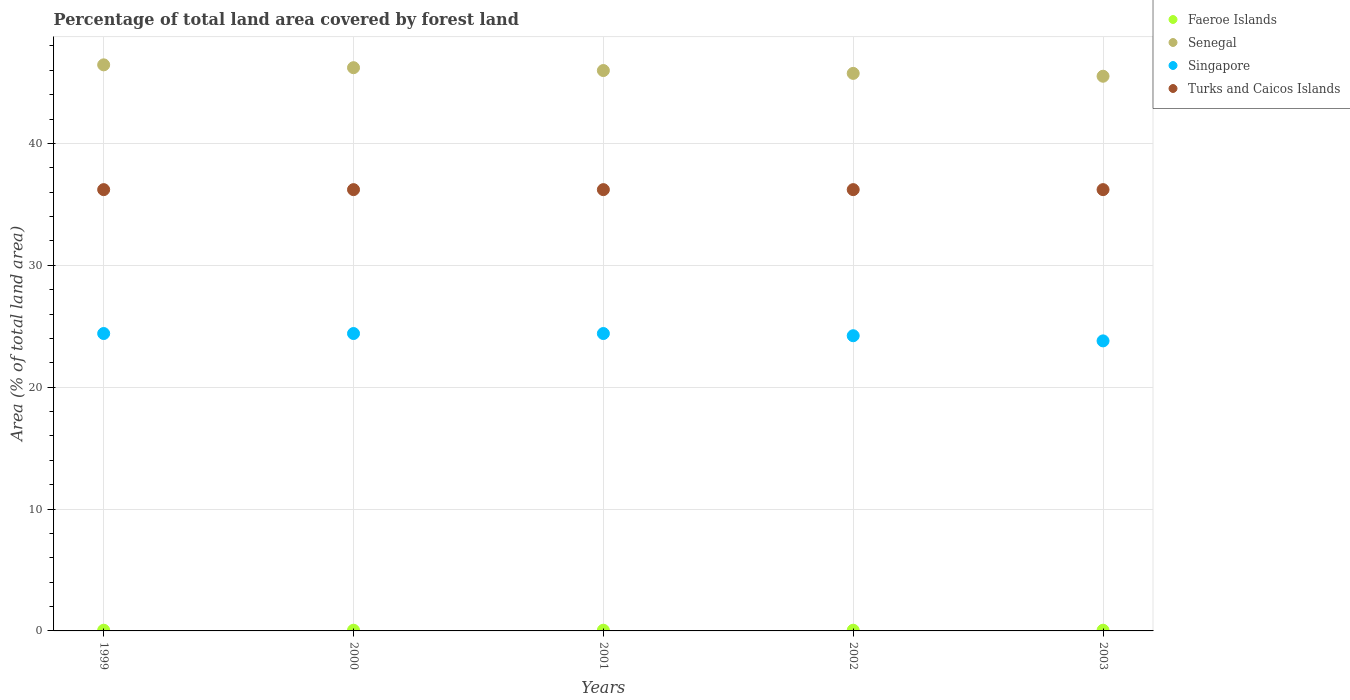How many different coloured dotlines are there?
Your answer should be very brief. 4. Is the number of dotlines equal to the number of legend labels?
Offer a very short reply. Yes. What is the percentage of forest land in Singapore in 2003?
Give a very brief answer. 23.8. Across all years, what is the maximum percentage of forest land in Faeroe Islands?
Provide a succinct answer. 0.06. Across all years, what is the minimum percentage of forest land in Turks and Caicos Islands?
Provide a short and direct response. 36.21. What is the total percentage of forest land in Singapore in the graph?
Offer a terse response. 121.23. What is the difference between the percentage of forest land in Senegal in 2001 and that in 2002?
Ensure brevity in your answer.  0.23. What is the difference between the percentage of forest land in Faeroe Islands in 2003 and the percentage of forest land in Singapore in 2001?
Your answer should be very brief. -24.35. What is the average percentage of forest land in Turks and Caicos Islands per year?
Your response must be concise. 36.21. In the year 2002, what is the difference between the percentage of forest land in Senegal and percentage of forest land in Singapore?
Give a very brief answer. 21.53. In how many years, is the percentage of forest land in Faeroe Islands greater than 26 %?
Offer a terse response. 0. What is the ratio of the percentage of forest land in Turks and Caicos Islands in 1999 to that in 2002?
Your answer should be compact. 1. What is the difference between the highest and the second highest percentage of forest land in Senegal?
Your answer should be very brief. 0.23. What is the difference between the highest and the lowest percentage of forest land in Senegal?
Ensure brevity in your answer.  0.93. In how many years, is the percentage of forest land in Faeroe Islands greater than the average percentage of forest land in Faeroe Islands taken over all years?
Offer a terse response. 5. Is it the case that in every year, the sum of the percentage of forest land in Singapore and percentage of forest land in Faeroe Islands  is greater than the sum of percentage of forest land in Senegal and percentage of forest land in Turks and Caicos Islands?
Provide a short and direct response. No. Is it the case that in every year, the sum of the percentage of forest land in Senegal and percentage of forest land in Turks and Caicos Islands  is greater than the percentage of forest land in Singapore?
Offer a terse response. Yes. Does the percentage of forest land in Faeroe Islands monotonically increase over the years?
Provide a succinct answer. No. Is the percentage of forest land in Senegal strictly less than the percentage of forest land in Singapore over the years?
Give a very brief answer. No. How many dotlines are there?
Ensure brevity in your answer.  4. Are the values on the major ticks of Y-axis written in scientific E-notation?
Offer a very short reply. No. Does the graph contain any zero values?
Give a very brief answer. No. Does the graph contain grids?
Your answer should be very brief. Yes. Where does the legend appear in the graph?
Your answer should be very brief. Top right. What is the title of the graph?
Your answer should be very brief. Percentage of total land area covered by forest land. Does "Gambia, The" appear as one of the legend labels in the graph?
Offer a terse response. No. What is the label or title of the X-axis?
Keep it short and to the point. Years. What is the label or title of the Y-axis?
Give a very brief answer. Area (% of total land area). What is the Area (% of total land area) of Faeroe Islands in 1999?
Provide a succinct answer. 0.06. What is the Area (% of total land area) of Senegal in 1999?
Offer a terse response. 46.45. What is the Area (% of total land area) of Singapore in 1999?
Keep it short and to the point. 24.4. What is the Area (% of total land area) in Turks and Caicos Islands in 1999?
Offer a very short reply. 36.21. What is the Area (% of total land area) in Faeroe Islands in 2000?
Offer a very short reply. 0.06. What is the Area (% of total land area) in Senegal in 2000?
Make the answer very short. 46.22. What is the Area (% of total land area) of Singapore in 2000?
Ensure brevity in your answer.  24.4. What is the Area (% of total land area) of Turks and Caicos Islands in 2000?
Give a very brief answer. 36.21. What is the Area (% of total land area) in Faeroe Islands in 2001?
Provide a succinct answer. 0.06. What is the Area (% of total land area) of Senegal in 2001?
Make the answer very short. 45.98. What is the Area (% of total land area) in Singapore in 2001?
Your answer should be very brief. 24.4. What is the Area (% of total land area) of Turks and Caicos Islands in 2001?
Keep it short and to the point. 36.21. What is the Area (% of total land area) in Faeroe Islands in 2002?
Your response must be concise. 0.06. What is the Area (% of total land area) in Senegal in 2002?
Provide a short and direct response. 45.75. What is the Area (% of total land area) of Singapore in 2002?
Your answer should be very brief. 24.22. What is the Area (% of total land area) of Turks and Caicos Islands in 2002?
Keep it short and to the point. 36.21. What is the Area (% of total land area) of Faeroe Islands in 2003?
Provide a short and direct response. 0.06. What is the Area (% of total land area) in Senegal in 2003?
Make the answer very short. 45.51. What is the Area (% of total land area) in Singapore in 2003?
Give a very brief answer. 23.8. What is the Area (% of total land area) in Turks and Caicos Islands in 2003?
Offer a terse response. 36.21. Across all years, what is the maximum Area (% of total land area) of Faeroe Islands?
Provide a succinct answer. 0.06. Across all years, what is the maximum Area (% of total land area) in Senegal?
Make the answer very short. 46.45. Across all years, what is the maximum Area (% of total land area) in Singapore?
Offer a terse response. 24.4. Across all years, what is the maximum Area (% of total land area) of Turks and Caicos Islands?
Offer a terse response. 36.21. Across all years, what is the minimum Area (% of total land area) in Faeroe Islands?
Offer a very short reply. 0.06. Across all years, what is the minimum Area (% of total land area) in Senegal?
Provide a short and direct response. 45.51. Across all years, what is the minimum Area (% of total land area) of Singapore?
Your response must be concise. 23.8. Across all years, what is the minimum Area (% of total land area) of Turks and Caicos Islands?
Keep it short and to the point. 36.21. What is the total Area (% of total land area) in Faeroe Islands in the graph?
Keep it short and to the point. 0.29. What is the total Area (% of total land area) of Senegal in the graph?
Ensure brevity in your answer.  229.91. What is the total Area (% of total land area) of Singapore in the graph?
Offer a terse response. 121.23. What is the total Area (% of total land area) of Turks and Caicos Islands in the graph?
Your answer should be compact. 181.05. What is the difference between the Area (% of total land area) of Senegal in 1999 and that in 2000?
Offer a terse response. 0.23. What is the difference between the Area (% of total land area) in Singapore in 1999 and that in 2000?
Offer a very short reply. 0. What is the difference between the Area (% of total land area) in Turks and Caicos Islands in 1999 and that in 2000?
Provide a succinct answer. 0. What is the difference between the Area (% of total land area) in Faeroe Islands in 1999 and that in 2001?
Your response must be concise. 0. What is the difference between the Area (% of total land area) of Senegal in 1999 and that in 2001?
Offer a very short reply. 0.47. What is the difference between the Area (% of total land area) in Faeroe Islands in 1999 and that in 2002?
Offer a terse response. 0. What is the difference between the Area (% of total land area) of Senegal in 1999 and that in 2002?
Offer a terse response. 0.7. What is the difference between the Area (% of total land area) in Singapore in 1999 and that in 2002?
Your answer should be very brief. 0.18. What is the difference between the Area (% of total land area) in Senegal in 1999 and that in 2003?
Your response must be concise. 0.93. What is the difference between the Area (% of total land area) of Singapore in 1999 and that in 2003?
Keep it short and to the point. 0.6. What is the difference between the Area (% of total land area) in Turks and Caicos Islands in 1999 and that in 2003?
Ensure brevity in your answer.  0. What is the difference between the Area (% of total land area) in Senegal in 2000 and that in 2001?
Offer a very short reply. 0.23. What is the difference between the Area (% of total land area) of Singapore in 2000 and that in 2001?
Provide a short and direct response. 0. What is the difference between the Area (% of total land area) of Turks and Caicos Islands in 2000 and that in 2001?
Offer a terse response. 0. What is the difference between the Area (% of total land area) in Faeroe Islands in 2000 and that in 2002?
Offer a terse response. 0. What is the difference between the Area (% of total land area) in Senegal in 2000 and that in 2002?
Your answer should be compact. 0.47. What is the difference between the Area (% of total land area) of Singapore in 2000 and that in 2002?
Give a very brief answer. 0.18. What is the difference between the Area (% of total land area) in Turks and Caicos Islands in 2000 and that in 2002?
Keep it short and to the point. 0. What is the difference between the Area (% of total land area) in Senegal in 2000 and that in 2003?
Your answer should be compact. 0.7. What is the difference between the Area (% of total land area) in Singapore in 2000 and that in 2003?
Ensure brevity in your answer.  0.6. What is the difference between the Area (% of total land area) in Turks and Caicos Islands in 2000 and that in 2003?
Your answer should be very brief. 0. What is the difference between the Area (% of total land area) of Senegal in 2001 and that in 2002?
Keep it short and to the point. 0.23. What is the difference between the Area (% of total land area) in Singapore in 2001 and that in 2002?
Your answer should be compact. 0.18. What is the difference between the Area (% of total land area) of Faeroe Islands in 2001 and that in 2003?
Provide a short and direct response. 0. What is the difference between the Area (% of total land area) in Senegal in 2001 and that in 2003?
Keep it short and to the point. 0.47. What is the difference between the Area (% of total land area) in Singapore in 2001 and that in 2003?
Offer a terse response. 0.6. What is the difference between the Area (% of total land area) of Turks and Caicos Islands in 2001 and that in 2003?
Provide a short and direct response. 0. What is the difference between the Area (% of total land area) in Senegal in 2002 and that in 2003?
Provide a succinct answer. 0.23. What is the difference between the Area (% of total land area) in Singapore in 2002 and that in 2003?
Provide a short and direct response. 0.42. What is the difference between the Area (% of total land area) of Turks and Caicos Islands in 2002 and that in 2003?
Offer a terse response. 0. What is the difference between the Area (% of total land area) in Faeroe Islands in 1999 and the Area (% of total land area) in Senegal in 2000?
Provide a short and direct response. -46.16. What is the difference between the Area (% of total land area) of Faeroe Islands in 1999 and the Area (% of total land area) of Singapore in 2000?
Keep it short and to the point. -24.35. What is the difference between the Area (% of total land area) in Faeroe Islands in 1999 and the Area (% of total land area) in Turks and Caicos Islands in 2000?
Provide a short and direct response. -36.15. What is the difference between the Area (% of total land area) of Senegal in 1999 and the Area (% of total land area) of Singapore in 2000?
Make the answer very short. 22.05. What is the difference between the Area (% of total land area) of Senegal in 1999 and the Area (% of total land area) of Turks and Caicos Islands in 2000?
Provide a succinct answer. 10.24. What is the difference between the Area (% of total land area) of Singapore in 1999 and the Area (% of total land area) of Turks and Caicos Islands in 2000?
Your answer should be very brief. -11.81. What is the difference between the Area (% of total land area) in Faeroe Islands in 1999 and the Area (% of total land area) in Senegal in 2001?
Offer a very short reply. -45.93. What is the difference between the Area (% of total land area) of Faeroe Islands in 1999 and the Area (% of total land area) of Singapore in 2001?
Provide a succinct answer. -24.35. What is the difference between the Area (% of total land area) in Faeroe Islands in 1999 and the Area (% of total land area) in Turks and Caicos Islands in 2001?
Make the answer very short. -36.15. What is the difference between the Area (% of total land area) of Senegal in 1999 and the Area (% of total land area) of Singapore in 2001?
Ensure brevity in your answer.  22.05. What is the difference between the Area (% of total land area) of Senegal in 1999 and the Area (% of total land area) of Turks and Caicos Islands in 2001?
Offer a terse response. 10.24. What is the difference between the Area (% of total land area) in Singapore in 1999 and the Area (% of total land area) in Turks and Caicos Islands in 2001?
Offer a very short reply. -11.81. What is the difference between the Area (% of total land area) of Faeroe Islands in 1999 and the Area (% of total land area) of Senegal in 2002?
Offer a terse response. -45.69. What is the difference between the Area (% of total land area) in Faeroe Islands in 1999 and the Area (% of total land area) in Singapore in 2002?
Provide a short and direct response. -24.16. What is the difference between the Area (% of total land area) in Faeroe Islands in 1999 and the Area (% of total land area) in Turks and Caicos Islands in 2002?
Your answer should be very brief. -36.15. What is the difference between the Area (% of total land area) of Senegal in 1999 and the Area (% of total land area) of Singapore in 2002?
Give a very brief answer. 22.23. What is the difference between the Area (% of total land area) of Senegal in 1999 and the Area (% of total land area) of Turks and Caicos Islands in 2002?
Provide a short and direct response. 10.24. What is the difference between the Area (% of total land area) in Singapore in 1999 and the Area (% of total land area) in Turks and Caicos Islands in 2002?
Offer a very short reply. -11.81. What is the difference between the Area (% of total land area) in Faeroe Islands in 1999 and the Area (% of total land area) in Senegal in 2003?
Offer a very short reply. -45.46. What is the difference between the Area (% of total land area) of Faeroe Islands in 1999 and the Area (% of total land area) of Singapore in 2003?
Give a very brief answer. -23.74. What is the difference between the Area (% of total land area) in Faeroe Islands in 1999 and the Area (% of total land area) in Turks and Caicos Islands in 2003?
Give a very brief answer. -36.15. What is the difference between the Area (% of total land area) in Senegal in 1999 and the Area (% of total land area) in Singapore in 2003?
Give a very brief answer. 22.65. What is the difference between the Area (% of total land area) of Senegal in 1999 and the Area (% of total land area) of Turks and Caicos Islands in 2003?
Offer a terse response. 10.24. What is the difference between the Area (% of total land area) in Singapore in 1999 and the Area (% of total land area) in Turks and Caicos Islands in 2003?
Give a very brief answer. -11.81. What is the difference between the Area (% of total land area) of Faeroe Islands in 2000 and the Area (% of total land area) of Senegal in 2001?
Provide a short and direct response. -45.93. What is the difference between the Area (% of total land area) in Faeroe Islands in 2000 and the Area (% of total land area) in Singapore in 2001?
Your answer should be compact. -24.35. What is the difference between the Area (% of total land area) of Faeroe Islands in 2000 and the Area (% of total land area) of Turks and Caicos Islands in 2001?
Ensure brevity in your answer.  -36.15. What is the difference between the Area (% of total land area) of Senegal in 2000 and the Area (% of total land area) of Singapore in 2001?
Your response must be concise. 21.81. What is the difference between the Area (% of total land area) of Senegal in 2000 and the Area (% of total land area) of Turks and Caicos Islands in 2001?
Provide a succinct answer. 10.01. What is the difference between the Area (% of total land area) of Singapore in 2000 and the Area (% of total land area) of Turks and Caicos Islands in 2001?
Your answer should be very brief. -11.81. What is the difference between the Area (% of total land area) in Faeroe Islands in 2000 and the Area (% of total land area) in Senegal in 2002?
Your response must be concise. -45.69. What is the difference between the Area (% of total land area) in Faeroe Islands in 2000 and the Area (% of total land area) in Singapore in 2002?
Keep it short and to the point. -24.16. What is the difference between the Area (% of total land area) in Faeroe Islands in 2000 and the Area (% of total land area) in Turks and Caicos Islands in 2002?
Keep it short and to the point. -36.15. What is the difference between the Area (% of total land area) in Senegal in 2000 and the Area (% of total land area) in Singapore in 2002?
Your answer should be compact. 21.99. What is the difference between the Area (% of total land area) of Senegal in 2000 and the Area (% of total land area) of Turks and Caicos Islands in 2002?
Your answer should be compact. 10.01. What is the difference between the Area (% of total land area) of Singapore in 2000 and the Area (% of total land area) of Turks and Caicos Islands in 2002?
Keep it short and to the point. -11.81. What is the difference between the Area (% of total land area) of Faeroe Islands in 2000 and the Area (% of total land area) of Senegal in 2003?
Give a very brief answer. -45.46. What is the difference between the Area (% of total land area) in Faeroe Islands in 2000 and the Area (% of total land area) in Singapore in 2003?
Make the answer very short. -23.74. What is the difference between the Area (% of total land area) in Faeroe Islands in 2000 and the Area (% of total land area) in Turks and Caicos Islands in 2003?
Your response must be concise. -36.15. What is the difference between the Area (% of total land area) of Senegal in 2000 and the Area (% of total land area) of Singapore in 2003?
Make the answer very short. 22.42. What is the difference between the Area (% of total land area) in Senegal in 2000 and the Area (% of total land area) in Turks and Caicos Islands in 2003?
Provide a succinct answer. 10.01. What is the difference between the Area (% of total land area) of Singapore in 2000 and the Area (% of total land area) of Turks and Caicos Islands in 2003?
Give a very brief answer. -11.81. What is the difference between the Area (% of total land area) in Faeroe Islands in 2001 and the Area (% of total land area) in Senegal in 2002?
Your response must be concise. -45.69. What is the difference between the Area (% of total land area) in Faeroe Islands in 2001 and the Area (% of total land area) in Singapore in 2002?
Your answer should be compact. -24.16. What is the difference between the Area (% of total land area) in Faeroe Islands in 2001 and the Area (% of total land area) in Turks and Caicos Islands in 2002?
Offer a terse response. -36.15. What is the difference between the Area (% of total land area) of Senegal in 2001 and the Area (% of total land area) of Singapore in 2002?
Give a very brief answer. 21.76. What is the difference between the Area (% of total land area) in Senegal in 2001 and the Area (% of total land area) in Turks and Caicos Islands in 2002?
Your answer should be very brief. 9.77. What is the difference between the Area (% of total land area) of Singapore in 2001 and the Area (% of total land area) of Turks and Caicos Islands in 2002?
Ensure brevity in your answer.  -11.81. What is the difference between the Area (% of total land area) in Faeroe Islands in 2001 and the Area (% of total land area) in Senegal in 2003?
Keep it short and to the point. -45.46. What is the difference between the Area (% of total land area) of Faeroe Islands in 2001 and the Area (% of total land area) of Singapore in 2003?
Your answer should be very brief. -23.74. What is the difference between the Area (% of total land area) in Faeroe Islands in 2001 and the Area (% of total land area) in Turks and Caicos Islands in 2003?
Provide a short and direct response. -36.15. What is the difference between the Area (% of total land area) of Senegal in 2001 and the Area (% of total land area) of Singapore in 2003?
Ensure brevity in your answer.  22.18. What is the difference between the Area (% of total land area) in Senegal in 2001 and the Area (% of total land area) in Turks and Caicos Islands in 2003?
Offer a terse response. 9.77. What is the difference between the Area (% of total land area) of Singapore in 2001 and the Area (% of total land area) of Turks and Caicos Islands in 2003?
Ensure brevity in your answer.  -11.81. What is the difference between the Area (% of total land area) of Faeroe Islands in 2002 and the Area (% of total land area) of Senegal in 2003?
Keep it short and to the point. -45.46. What is the difference between the Area (% of total land area) of Faeroe Islands in 2002 and the Area (% of total land area) of Singapore in 2003?
Offer a terse response. -23.74. What is the difference between the Area (% of total land area) of Faeroe Islands in 2002 and the Area (% of total land area) of Turks and Caicos Islands in 2003?
Give a very brief answer. -36.15. What is the difference between the Area (% of total land area) in Senegal in 2002 and the Area (% of total land area) in Singapore in 2003?
Your response must be concise. 21.95. What is the difference between the Area (% of total land area) of Senegal in 2002 and the Area (% of total land area) of Turks and Caicos Islands in 2003?
Give a very brief answer. 9.54. What is the difference between the Area (% of total land area) of Singapore in 2002 and the Area (% of total land area) of Turks and Caicos Islands in 2003?
Your answer should be very brief. -11.99. What is the average Area (% of total land area) of Faeroe Islands per year?
Your answer should be very brief. 0.06. What is the average Area (% of total land area) of Senegal per year?
Provide a short and direct response. 45.98. What is the average Area (% of total land area) in Singapore per year?
Ensure brevity in your answer.  24.25. What is the average Area (% of total land area) in Turks and Caicos Islands per year?
Make the answer very short. 36.21. In the year 1999, what is the difference between the Area (% of total land area) of Faeroe Islands and Area (% of total land area) of Senegal?
Keep it short and to the point. -46.39. In the year 1999, what is the difference between the Area (% of total land area) in Faeroe Islands and Area (% of total land area) in Singapore?
Offer a terse response. -24.35. In the year 1999, what is the difference between the Area (% of total land area) of Faeroe Islands and Area (% of total land area) of Turks and Caicos Islands?
Provide a short and direct response. -36.15. In the year 1999, what is the difference between the Area (% of total land area) of Senegal and Area (% of total land area) of Singapore?
Offer a very short reply. 22.05. In the year 1999, what is the difference between the Area (% of total land area) of Senegal and Area (% of total land area) of Turks and Caicos Islands?
Provide a succinct answer. 10.24. In the year 1999, what is the difference between the Area (% of total land area) in Singapore and Area (% of total land area) in Turks and Caicos Islands?
Provide a short and direct response. -11.81. In the year 2000, what is the difference between the Area (% of total land area) of Faeroe Islands and Area (% of total land area) of Senegal?
Ensure brevity in your answer.  -46.16. In the year 2000, what is the difference between the Area (% of total land area) in Faeroe Islands and Area (% of total land area) in Singapore?
Offer a very short reply. -24.35. In the year 2000, what is the difference between the Area (% of total land area) of Faeroe Islands and Area (% of total land area) of Turks and Caicos Islands?
Provide a short and direct response. -36.15. In the year 2000, what is the difference between the Area (% of total land area) in Senegal and Area (% of total land area) in Singapore?
Offer a terse response. 21.81. In the year 2000, what is the difference between the Area (% of total land area) in Senegal and Area (% of total land area) in Turks and Caicos Islands?
Your answer should be very brief. 10.01. In the year 2000, what is the difference between the Area (% of total land area) of Singapore and Area (% of total land area) of Turks and Caicos Islands?
Give a very brief answer. -11.81. In the year 2001, what is the difference between the Area (% of total land area) in Faeroe Islands and Area (% of total land area) in Senegal?
Your response must be concise. -45.93. In the year 2001, what is the difference between the Area (% of total land area) in Faeroe Islands and Area (% of total land area) in Singapore?
Your answer should be very brief. -24.35. In the year 2001, what is the difference between the Area (% of total land area) in Faeroe Islands and Area (% of total land area) in Turks and Caicos Islands?
Your answer should be very brief. -36.15. In the year 2001, what is the difference between the Area (% of total land area) in Senegal and Area (% of total land area) in Singapore?
Provide a short and direct response. 21.58. In the year 2001, what is the difference between the Area (% of total land area) in Senegal and Area (% of total land area) in Turks and Caicos Islands?
Ensure brevity in your answer.  9.77. In the year 2001, what is the difference between the Area (% of total land area) of Singapore and Area (% of total land area) of Turks and Caicos Islands?
Your answer should be very brief. -11.81. In the year 2002, what is the difference between the Area (% of total land area) in Faeroe Islands and Area (% of total land area) in Senegal?
Offer a very short reply. -45.69. In the year 2002, what is the difference between the Area (% of total land area) of Faeroe Islands and Area (% of total land area) of Singapore?
Provide a short and direct response. -24.16. In the year 2002, what is the difference between the Area (% of total land area) in Faeroe Islands and Area (% of total land area) in Turks and Caicos Islands?
Your answer should be very brief. -36.15. In the year 2002, what is the difference between the Area (% of total land area) of Senegal and Area (% of total land area) of Singapore?
Give a very brief answer. 21.53. In the year 2002, what is the difference between the Area (% of total land area) in Senegal and Area (% of total land area) in Turks and Caicos Islands?
Give a very brief answer. 9.54. In the year 2002, what is the difference between the Area (% of total land area) of Singapore and Area (% of total land area) of Turks and Caicos Islands?
Ensure brevity in your answer.  -11.99. In the year 2003, what is the difference between the Area (% of total land area) of Faeroe Islands and Area (% of total land area) of Senegal?
Provide a succinct answer. -45.46. In the year 2003, what is the difference between the Area (% of total land area) of Faeroe Islands and Area (% of total land area) of Singapore?
Ensure brevity in your answer.  -23.74. In the year 2003, what is the difference between the Area (% of total land area) of Faeroe Islands and Area (% of total land area) of Turks and Caicos Islands?
Ensure brevity in your answer.  -36.15. In the year 2003, what is the difference between the Area (% of total land area) in Senegal and Area (% of total land area) in Singapore?
Offer a very short reply. 21.72. In the year 2003, what is the difference between the Area (% of total land area) of Senegal and Area (% of total land area) of Turks and Caicos Islands?
Keep it short and to the point. 9.3. In the year 2003, what is the difference between the Area (% of total land area) of Singapore and Area (% of total land area) of Turks and Caicos Islands?
Ensure brevity in your answer.  -12.41. What is the ratio of the Area (% of total land area) in Senegal in 1999 to that in 2000?
Your answer should be compact. 1.01. What is the ratio of the Area (% of total land area) of Turks and Caicos Islands in 1999 to that in 2000?
Your answer should be compact. 1. What is the ratio of the Area (% of total land area) of Senegal in 1999 to that in 2001?
Offer a very short reply. 1.01. What is the ratio of the Area (% of total land area) of Faeroe Islands in 1999 to that in 2002?
Keep it short and to the point. 1. What is the ratio of the Area (% of total land area) in Senegal in 1999 to that in 2002?
Provide a short and direct response. 1.02. What is the ratio of the Area (% of total land area) of Singapore in 1999 to that in 2002?
Make the answer very short. 1.01. What is the ratio of the Area (% of total land area) of Faeroe Islands in 1999 to that in 2003?
Your answer should be very brief. 1. What is the ratio of the Area (% of total land area) in Senegal in 1999 to that in 2003?
Ensure brevity in your answer.  1.02. What is the ratio of the Area (% of total land area) in Singapore in 1999 to that in 2003?
Offer a terse response. 1.03. What is the ratio of the Area (% of total land area) in Turks and Caicos Islands in 1999 to that in 2003?
Ensure brevity in your answer.  1. What is the ratio of the Area (% of total land area) in Singapore in 2000 to that in 2001?
Offer a terse response. 1. What is the ratio of the Area (% of total land area) of Faeroe Islands in 2000 to that in 2002?
Provide a short and direct response. 1. What is the ratio of the Area (% of total land area) of Senegal in 2000 to that in 2002?
Make the answer very short. 1.01. What is the ratio of the Area (% of total land area) in Singapore in 2000 to that in 2002?
Provide a succinct answer. 1.01. What is the ratio of the Area (% of total land area) in Turks and Caicos Islands in 2000 to that in 2002?
Keep it short and to the point. 1. What is the ratio of the Area (% of total land area) in Faeroe Islands in 2000 to that in 2003?
Offer a terse response. 1. What is the ratio of the Area (% of total land area) in Senegal in 2000 to that in 2003?
Provide a succinct answer. 1.02. What is the ratio of the Area (% of total land area) of Singapore in 2000 to that in 2003?
Your answer should be compact. 1.03. What is the ratio of the Area (% of total land area) in Senegal in 2001 to that in 2002?
Ensure brevity in your answer.  1.01. What is the ratio of the Area (% of total land area) of Singapore in 2001 to that in 2002?
Your response must be concise. 1.01. What is the ratio of the Area (% of total land area) of Senegal in 2001 to that in 2003?
Provide a short and direct response. 1.01. What is the ratio of the Area (% of total land area) in Singapore in 2001 to that in 2003?
Provide a short and direct response. 1.03. What is the ratio of the Area (% of total land area) of Faeroe Islands in 2002 to that in 2003?
Ensure brevity in your answer.  1. What is the ratio of the Area (% of total land area) of Singapore in 2002 to that in 2003?
Ensure brevity in your answer.  1.02. What is the difference between the highest and the second highest Area (% of total land area) in Faeroe Islands?
Offer a very short reply. 0. What is the difference between the highest and the second highest Area (% of total land area) in Senegal?
Your response must be concise. 0.23. What is the difference between the highest and the second highest Area (% of total land area) of Singapore?
Provide a succinct answer. 0. What is the difference between the highest and the second highest Area (% of total land area) in Turks and Caicos Islands?
Your response must be concise. 0. What is the difference between the highest and the lowest Area (% of total land area) in Faeroe Islands?
Make the answer very short. 0. What is the difference between the highest and the lowest Area (% of total land area) of Senegal?
Your response must be concise. 0.93. What is the difference between the highest and the lowest Area (% of total land area) of Singapore?
Your answer should be very brief. 0.6. What is the difference between the highest and the lowest Area (% of total land area) of Turks and Caicos Islands?
Your response must be concise. 0. 